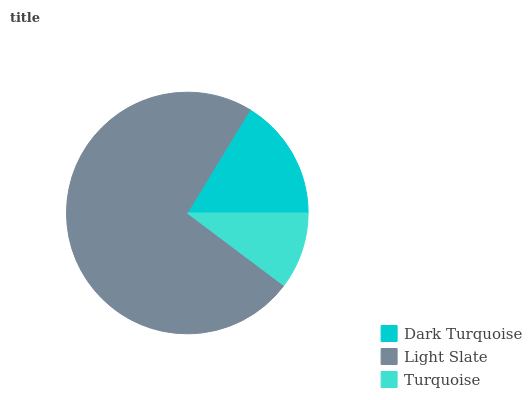Is Turquoise the minimum?
Answer yes or no. Yes. Is Light Slate the maximum?
Answer yes or no. Yes. Is Light Slate the minimum?
Answer yes or no. No. Is Turquoise the maximum?
Answer yes or no. No. Is Light Slate greater than Turquoise?
Answer yes or no. Yes. Is Turquoise less than Light Slate?
Answer yes or no. Yes. Is Turquoise greater than Light Slate?
Answer yes or no. No. Is Light Slate less than Turquoise?
Answer yes or no. No. Is Dark Turquoise the high median?
Answer yes or no. Yes. Is Dark Turquoise the low median?
Answer yes or no. Yes. Is Turquoise the high median?
Answer yes or no. No. Is Turquoise the low median?
Answer yes or no. No. 